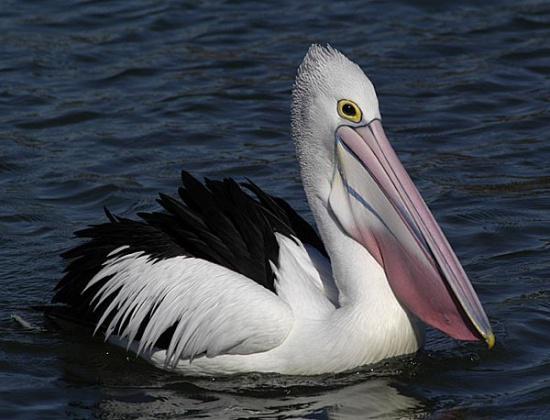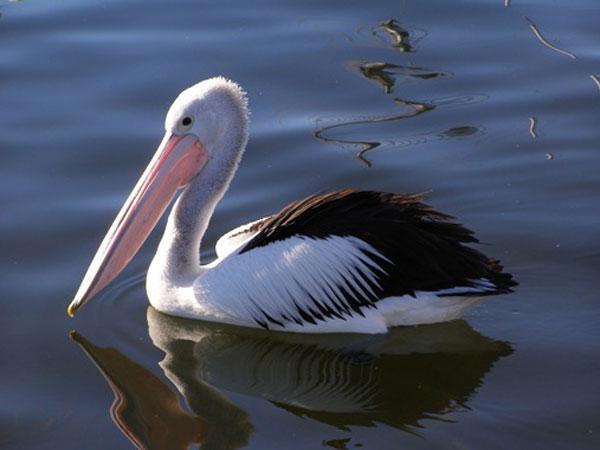The first image is the image on the left, the second image is the image on the right. Considering the images on both sides, is "One image shows a pelican in flight." valid? Answer yes or no. No. 